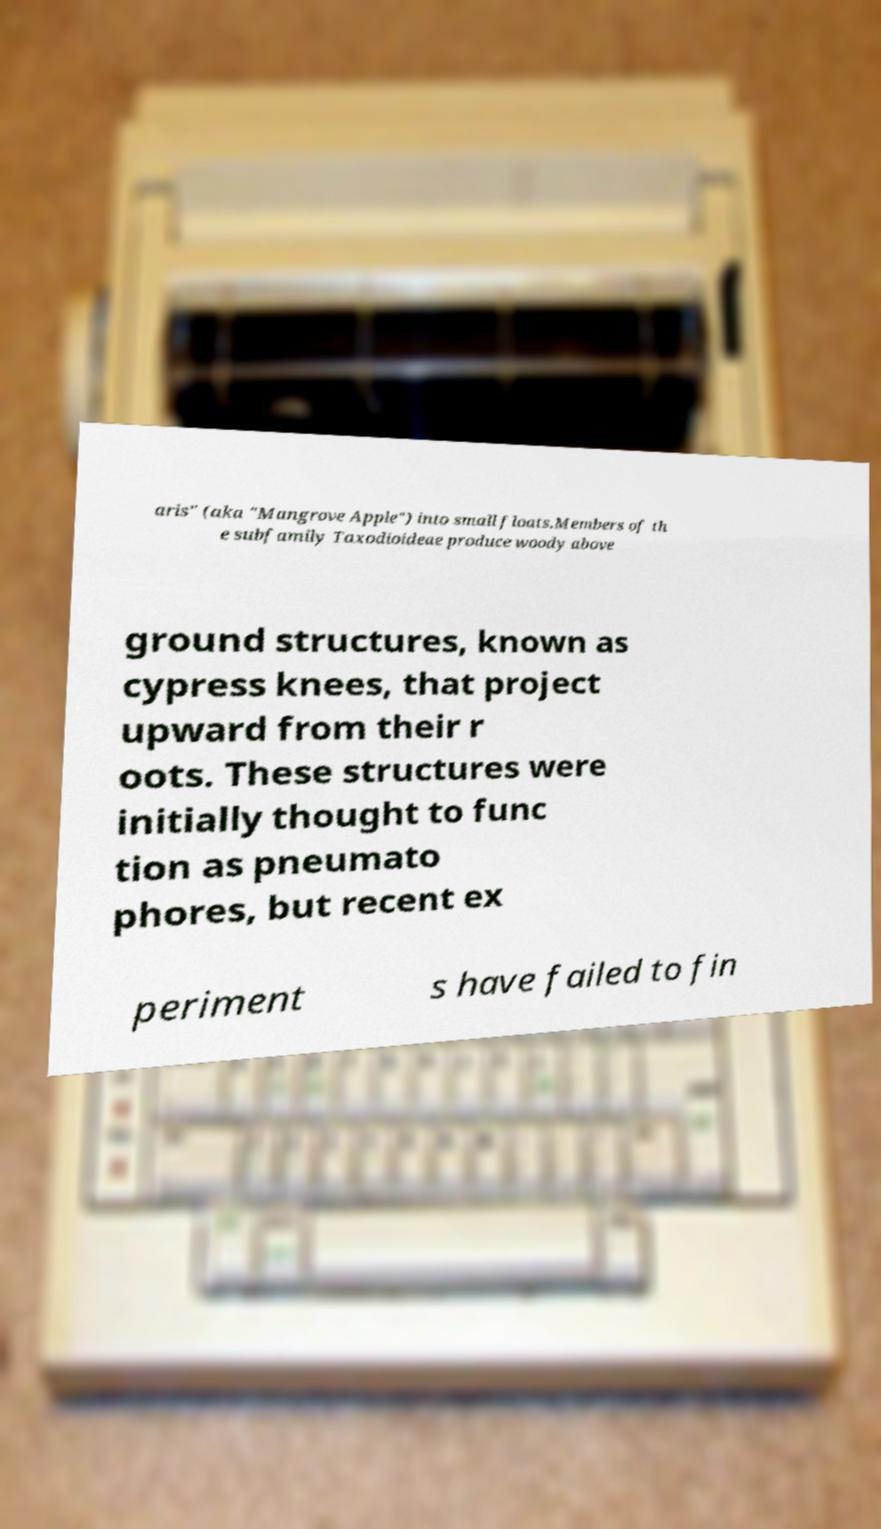Can you read and provide the text displayed in the image?This photo seems to have some interesting text. Can you extract and type it out for me? aris" (aka "Mangrove Apple") into small floats.Members of th e subfamily Taxodioideae produce woody above ground structures, known as cypress knees, that project upward from their r oots. These structures were initially thought to func tion as pneumato phores, but recent ex periment s have failed to fin 